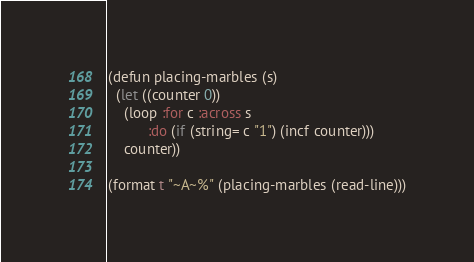Convert code to text. <code><loc_0><loc_0><loc_500><loc_500><_Lisp_>(defun placing-marbles (s)
  (let ((counter 0))
    (loop :for c :across s
          :do (if (string= c "1") (incf counter)))
    counter))

(format t "~A~%" (placing-marbles (read-line)))</code> 